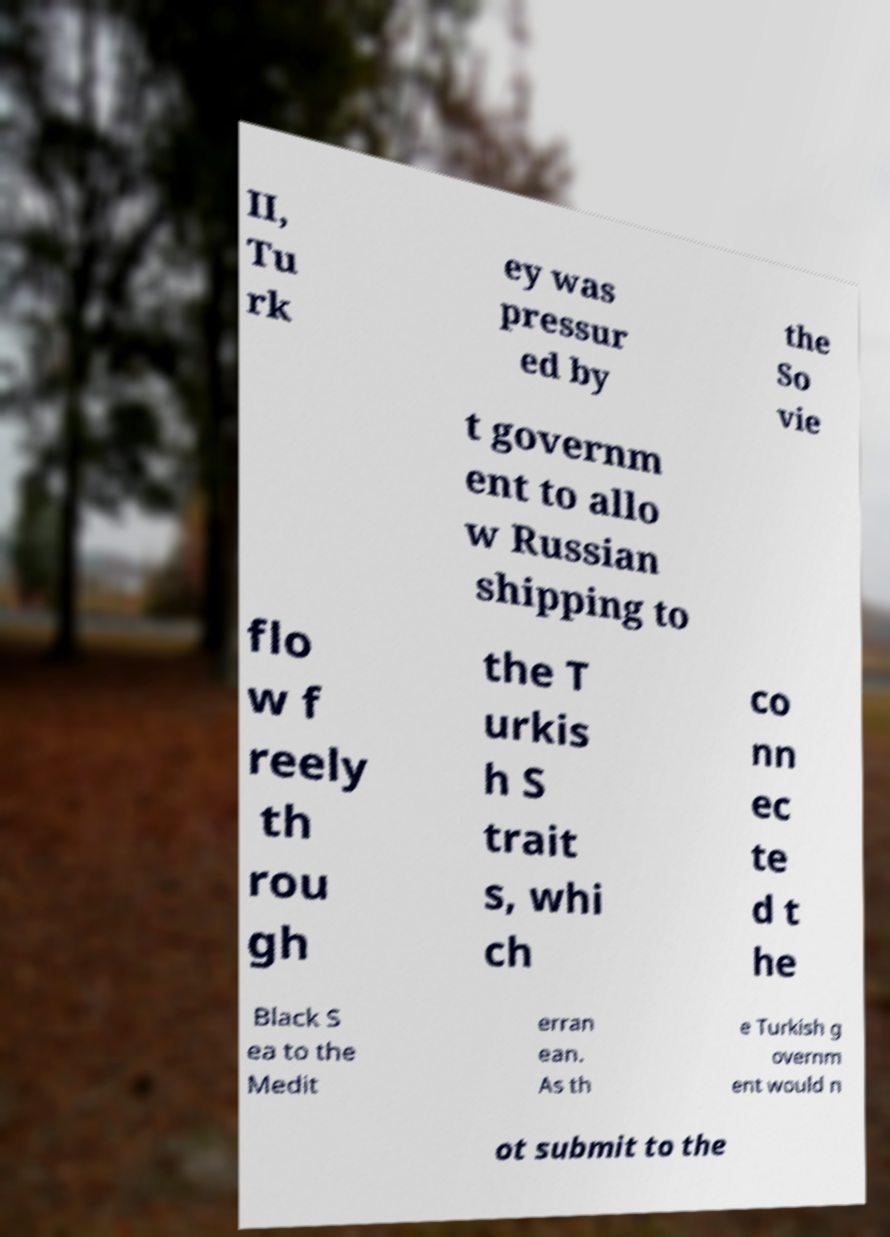Please identify and transcribe the text found in this image. II, Tu rk ey was pressur ed by the So vie t governm ent to allo w Russian shipping to flo w f reely th rou gh the T urkis h S trait s, whi ch co nn ec te d t he Black S ea to the Medit erran ean. As th e Turkish g overnm ent would n ot submit to the 